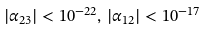<formula> <loc_0><loc_0><loc_500><loc_500>| \alpha _ { 2 3 } | < 1 0 ^ { - 2 2 } , \, | \alpha _ { 1 2 } | < 1 0 ^ { - 1 7 }</formula> 